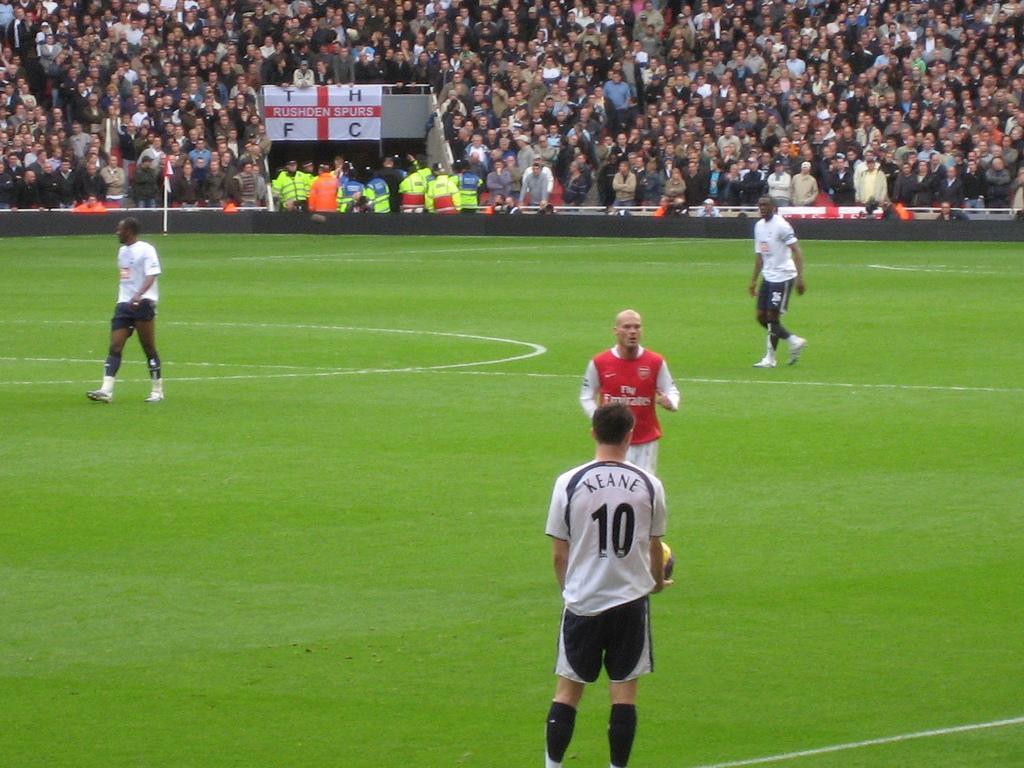In one or two sentences, can you explain what this image depicts? In this image we can see some people on the ground. On the backside we can see a group of people, a fence, the flag to a pole and a banner with some text on it. 